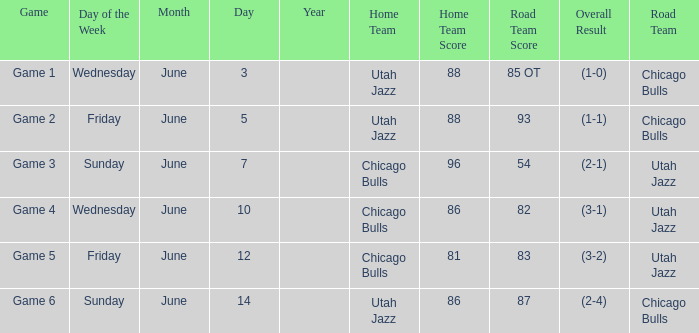Result of 88-85 ot (1-0) involves what game? Game 1. 